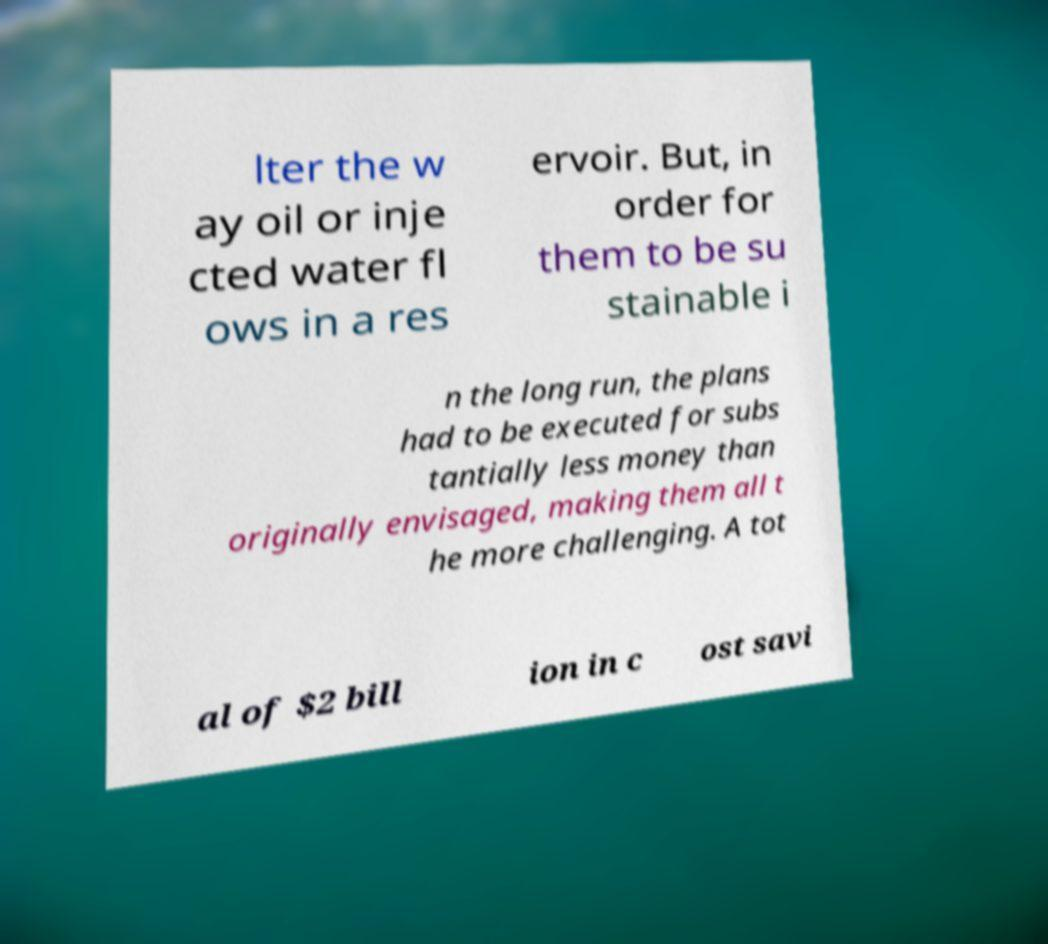I need the written content from this picture converted into text. Can you do that? lter the w ay oil or inje cted water fl ows in a res ervoir. But, in order for them to be su stainable i n the long run, the plans had to be executed for subs tantially less money than originally envisaged, making them all t he more challenging. A tot al of $2 bill ion in c ost savi 